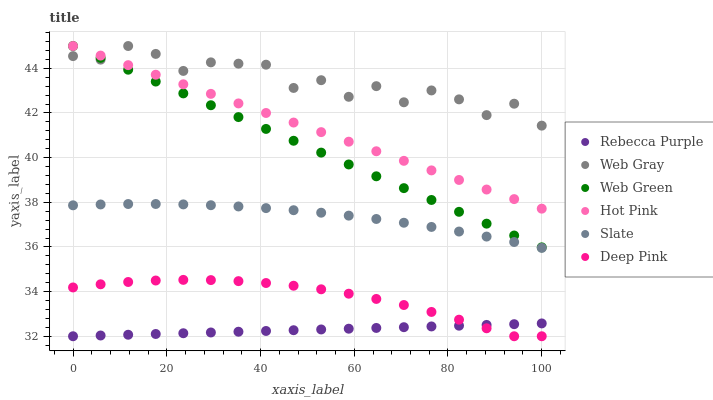Does Rebecca Purple have the minimum area under the curve?
Answer yes or no. Yes. Does Web Gray have the maximum area under the curve?
Answer yes or no. Yes. Does Slate have the minimum area under the curve?
Answer yes or no. No. Does Slate have the maximum area under the curve?
Answer yes or no. No. Is Hot Pink the smoothest?
Answer yes or no. Yes. Is Web Gray the roughest?
Answer yes or no. Yes. Is Slate the smoothest?
Answer yes or no. No. Is Slate the roughest?
Answer yes or no. No. Does Deep Pink have the lowest value?
Answer yes or no. Yes. Does Slate have the lowest value?
Answer yes or no. No. Does Web Gray have the highest value?
Answer yes or no. Yes. Does Slate have the highest value?
Answer yes or no. No. Is Deep Pink less than Web Green?
Answer yes or no. Yes. Is Hot Pink greater than Rebecca Purple?
Answer yes or no. Yes. Does Hot Pink intersect Web Green?
Answer yes or no. Yes. Is Hot Pink less than Web Green?
Answer yes or no. No. Is Hot Pink greater than Web Green?
Answer yes or no. No. Does Deep Pink intersect Web Green?
Answer yes or no. No. 